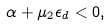Convert formula to latex. <formula><loc_0><loc_0><loc_500><loc_500>\alpha + \mu _ { 2 } \epsilon _ { d } < 0 ,</formula> 